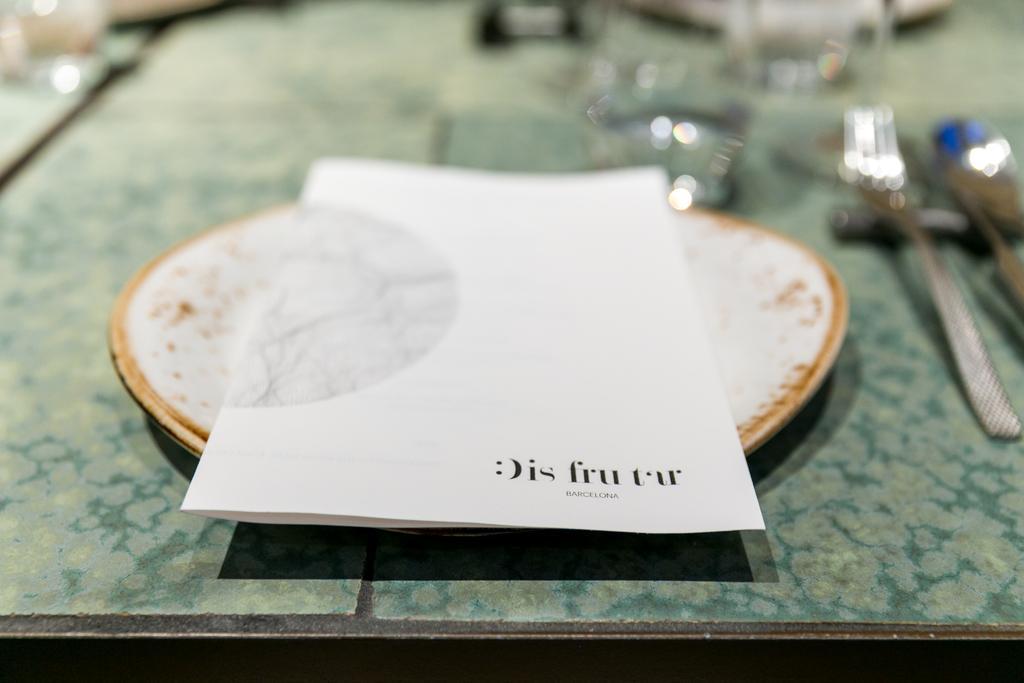Describe this image in one or two sentences. In this image there is one paper is kept in a plate as we can see in middle of this image and there are some objects kept at right side of this image. 